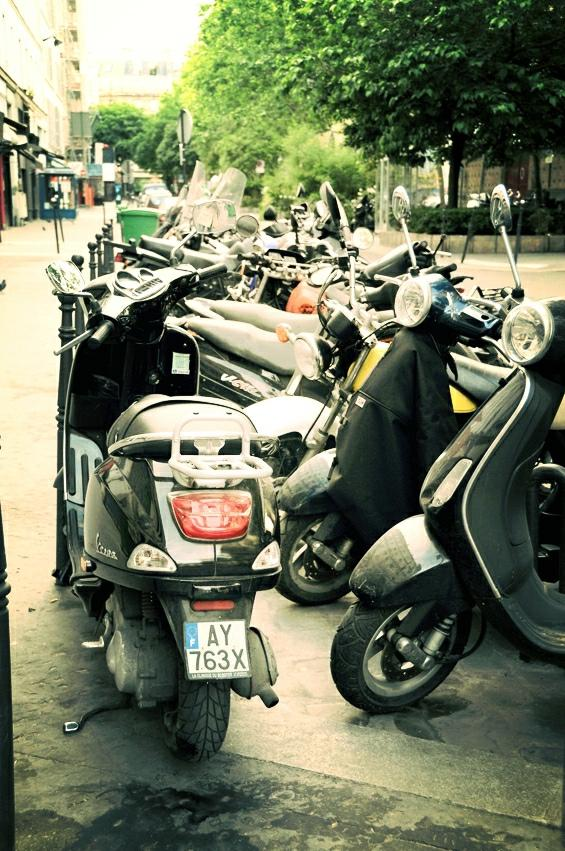Question: where does ay 763x appear?
Choices:
A. On a paper.
B. In the newspaper.
C. On a license plate.
D. In a library.
Answer with the letter. Answer: C Question: what is growing in the courtyard?
Choices:
A. Flowers.
B. Bushes.
C. Trees.
D. Cactus.
Answer with the letter. Answer: C Question: what vehicle is shown?
Choices:
A. Bicycle.
B. Motorcycle.
C. Scooter.
D. Moped.
Answer with the letter. Answer: D Question: when is the photo taken?
Choices:
A. At night.
B. In the morning.
C. During the day.
D. Under a full moon.
Answer with the letter. Answer: C Question: who is in view?
Choices:
A. No one.
B. A stranger.
C. A friend.
D. My child.
Answer with the letter. Answer: A Question: what vehicles are parked?
Choices:
A. Cars.
B. Mopeds and scooters.
C. Trucks.
D. Buses.
Answer with the letter. Answer: B Question: how many people are there?
Choices:
A. Two.
B. Three.
C. Four.
D. No people.
Answer with the letter. Answer: D Question: what color is the road?
Choices:
A. Black.
B. White.
C. Yellow and red.
D. Grey.
Answer with the letter. Answer: D Question: where was this photo taken?
Choices:
A. In a parking lot.
B. On a mountain.
C. In a bedroom.
D. In a library.
Answer with the letter. Answer: A Question: where was this photo taken?
Choices:
A. Downtown.
B. Town square.
C. In a city parking lot.
D. River bank.
Answer with the letter. Answer: C Question: what has leaves?
Choices:
A. The plants.
B. The trees.
C. The flowers.
D. The bag of yard clippings.
Answer with the letter. Answer: B Question: what is parked?
Choices:
A. The cars.
B. The buses.
C. The trucks.
D. The motorcycles.
Answer with the letter. Answer: D Question: what does the license plate on the motorcycle in the foreground look like?
Choices:
A. It is blue yellow lettering.
B. It is white with black lettering.
C. It is red with white lettering.
D. It has a big blue whale on it.
Answer with the letter. Answer: B Question: what shape are the motorcycle's headlights?
Choices:
A. Oval.
B. Oblong.
C. Round.
D. Octagonal.
Answer with the letter. Answer: C Question: how many people are in the picture?
Choices:
A. One.
B. Two.
C. Zero.
D. Three.
Answer with the letter. Answer: C Question: what is shining in the back of the picture?
Choices:
A. The lights.
B. The sun.
C. The lake.
D. The children.
Answer with the letter. Answer: B Question: what is facing a different way?
Choices:
A. One motorbike.
B. The train.
C. The man in the red hat.
D. The arrow.
Answer with the letter. Answer: A 